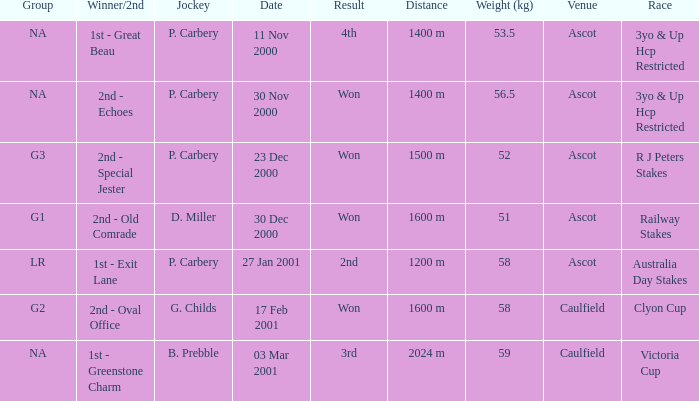What group info is available for the 56.5 kg weight? NA. 